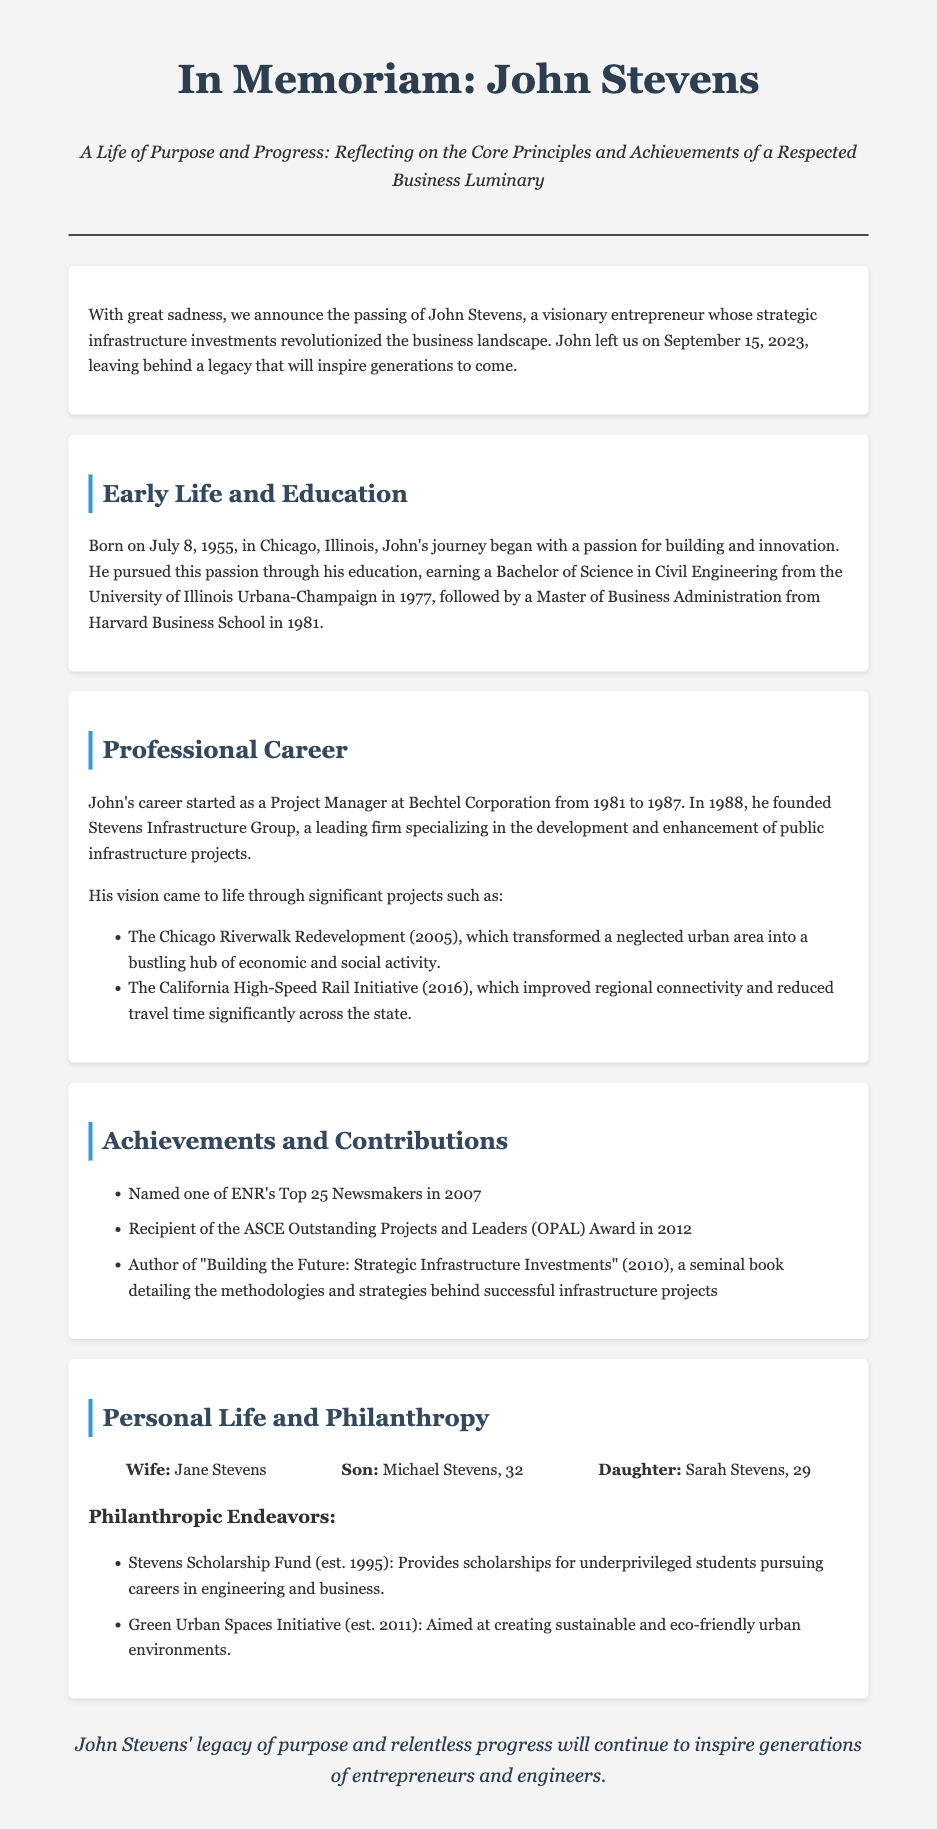What is John Stevens' date of birth? John Stevens was born on July 8, 1955, as mentioned in the early life section.
Answer: July 8, 1955 What degree did John earn from Harvard Business School? The document states he earned a Master of Business Administration from Harvard Business School.
Answer: Master of Business Administration What was the name of the company John founded? The obituary mentions that John founded Stevens Infrastructure Group in 1988.
Answer: Stevens Infrastructure Group What award did John receive in 2012? According to the achievements section, he received the ASCE Outstanding Projects and Leaders (OPAL) Award in 2012.
Answer: ASCE Outstanding Projects and Leaders (OPAL) Award What is the focus of the Stevens Scholarship Fund? The document describes the Stevens Scholarship Fund as providing scholarships for underprivileged students pursuing careers in engineering and business.
Answer: Scholarships for underprivileged students pursuing careers in engineering and business How many children did John Stevens have? The document lists John Stevens' family, including a son and a daughter, indicating he had two children.
Answer: Two What notable project was completed in 2005? The Chicago Riverwalk Redevelopment is mentioned as a significant project completed in 2005.
Answer: Chicago Riverwalk Redevelopment What was the purpose of the Green Urban Spaces Initiative? The document states that the initiative aims at creating sustainable and eco-friendly urban environments.
Answer: Creating sustainable and eco-friendly urban environments What year did John pass away? The obituary indicates that John Stevens passed away on September 15, 2023.
Answer: September 15, 2023 